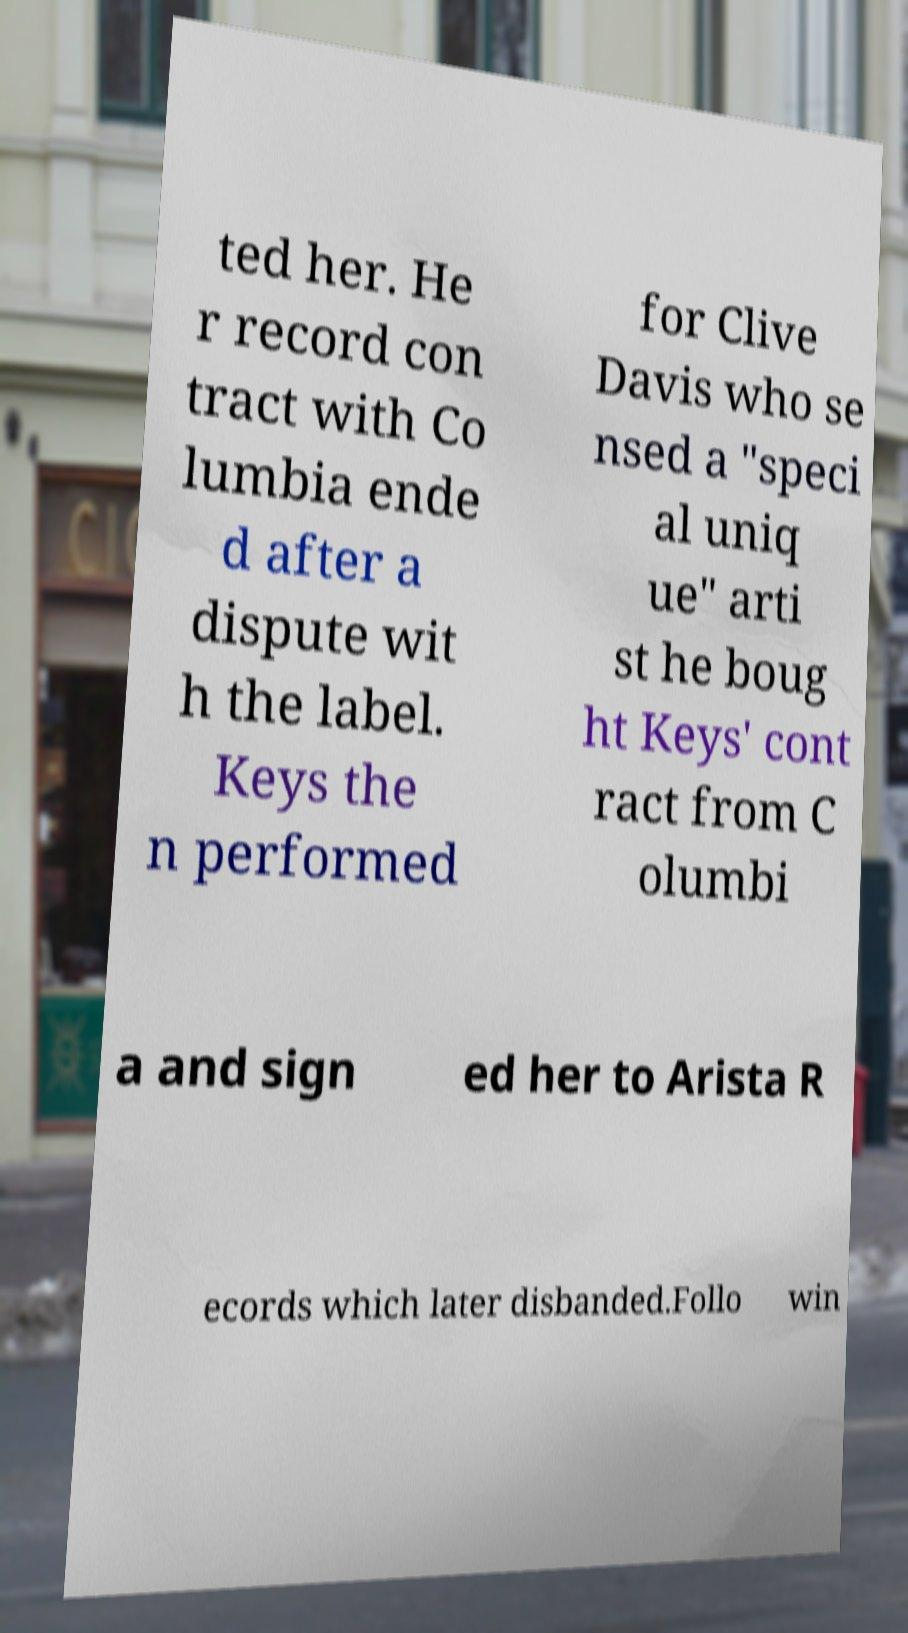Could you assist in decoding the text presented in this image and type it out clearly? ted her. He r record con tract with Co lumbia ende d after a dispute wit h the label. Keys the n performed for Clive Davis who se nsed a "speci al uniq ue" arti st he boug ht Keys' cont ract from C olumbi a and sign ed her to Arista R ecords which later disbanded.Follo win 